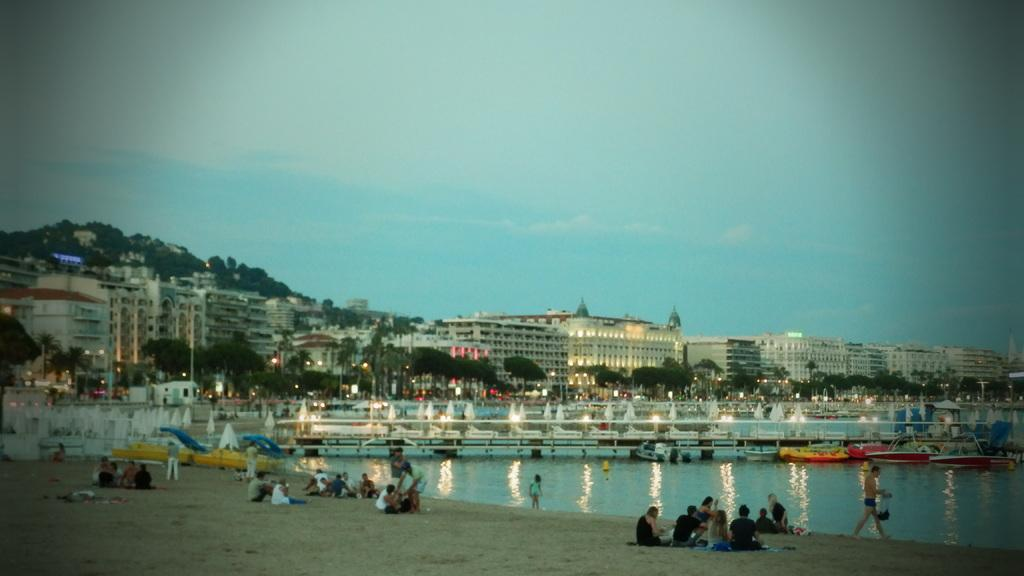How many people are in the image? There are persons in the image, but the exact number is not specified. What type of terrain is visible in the image? There is sand in the image. What can be seen on the water in the image? There are boats on water in the image. What structures are visible in the background of the image? There are buildings in the background of the image. What type of vegetation is visible in the background of the image? There are trees in the background of the image. What type of lighting is present in the background of the image? There are lights in the background of the image. What is visible in the sky in the background of the image? The sky is visible in the background of the image. What language is being spoken by the persons in the image? The provided facts do not mention any language being spoken in the image. What type of wine is being served on the beach in the image? There is no mention of wine or any beverages in the image. 